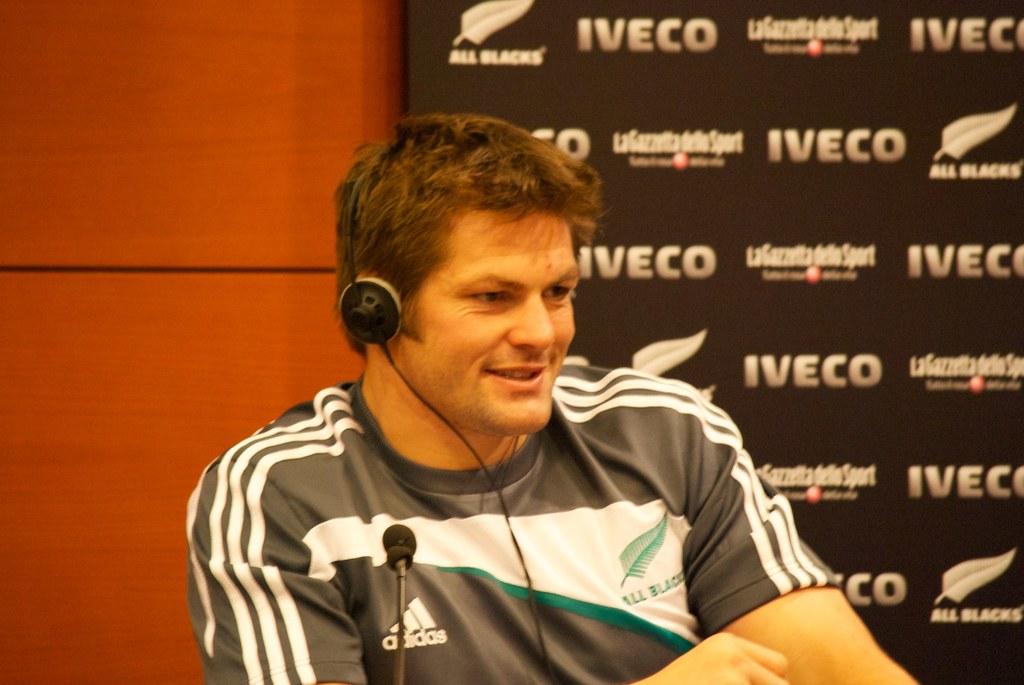What does it say on the right side of the man's shirt?
Make the answer very short. All black. 